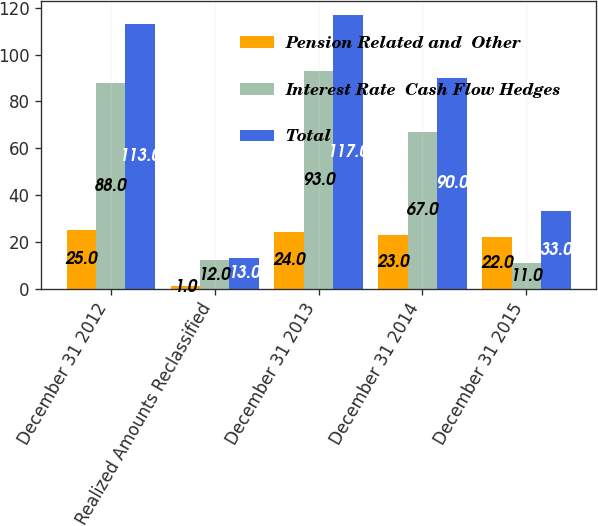<chart> <loc_0><loc_0><loc_500><loc_500><stacked_bar_chart><ecel><fcel>December 31 2012<fcel>Realized Amounts Reclassified<fcel>December 31 2013<fcel>December 31 2014<fcel>December 31 2015<nl><fcel>Pension Related and  Other<fcel>25<fcel>1<fcel>24<fcel>23<fcel>22<nl><fcel>Interest Rate  Cash Flow Hedges<fcel>88<fcel>12<fcel>93<fcel>67<fcel>11<nl><fcel>Total<fcel>113<fcel>13<fcel>117<fcel>90<fcel>33<nl></chart> 